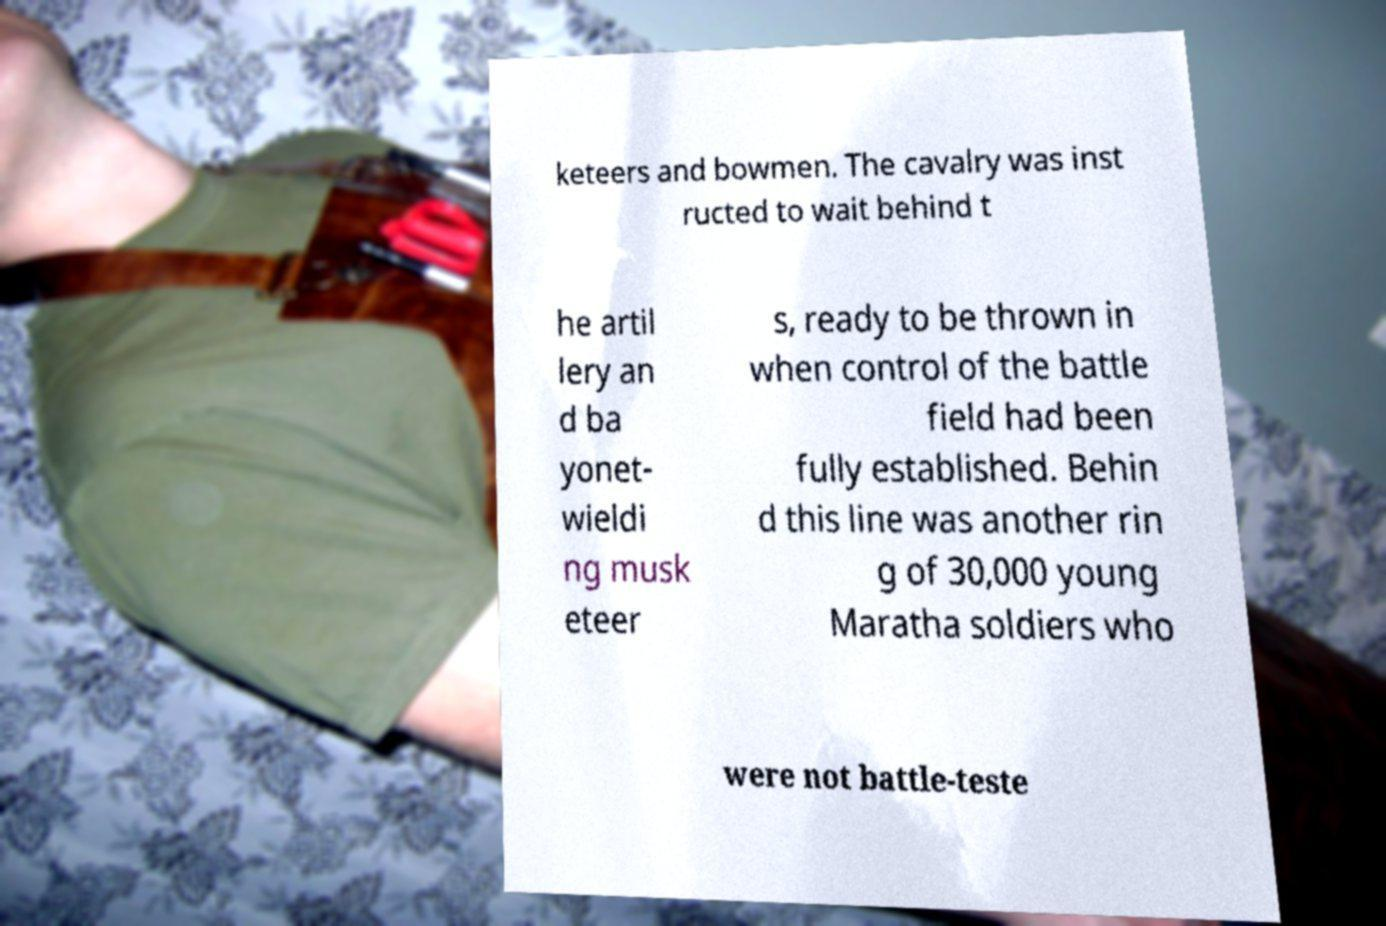Can you read and provide the text displayed in the image?This photo seems to have some interesting text. Can you extract and type it out for me? keteers and bowmen. The cavalry was inst ructed to wait behind t he artil lery an d ba yonet- wieldi ng musk eteer s, ready to be thrown in when control of the battle field had been fully established. Behin d this line was another rin g of 30,000 young Maratha soldiers who were not battle-teste 